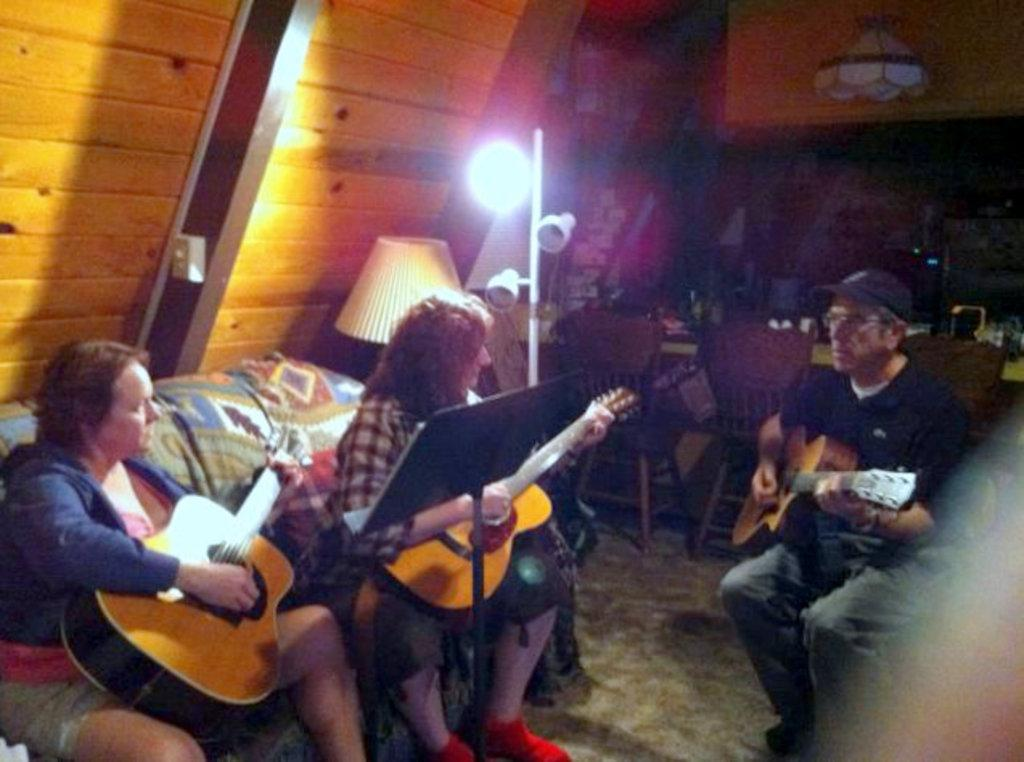Who or what can be seen in the image? There are people in the image. What are the people doing in the image? The people are sitting on chairs. What objects are the people holding in their hands? The people are holding guitars in their hands. Can you see any observations or roots in the image? There are no observations or roots present in the image. Is there a nest visible in the image? There is no nest visible in the image. 